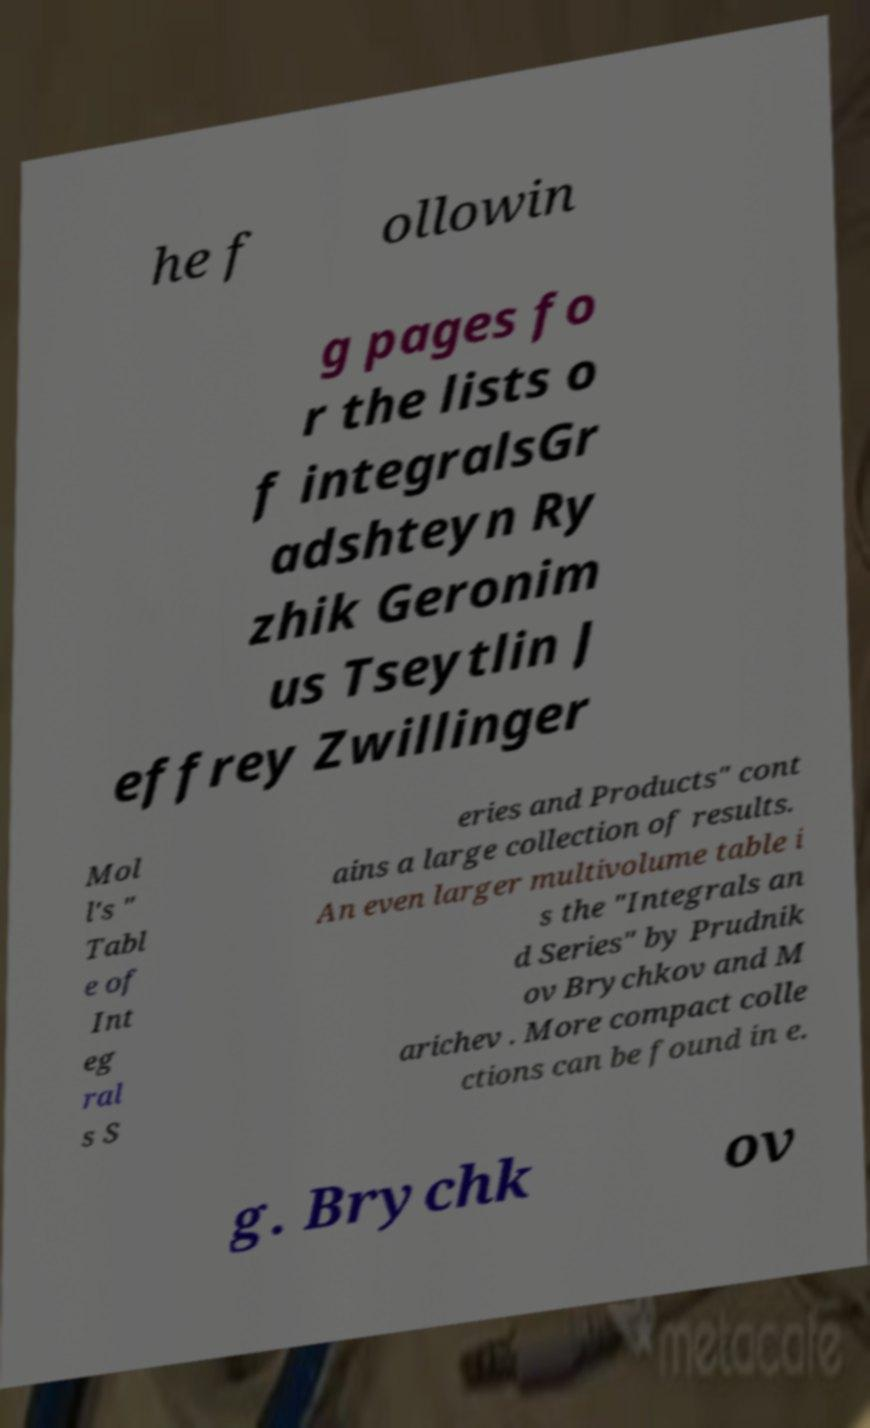Can you accurately transcribe the text from the provided image for me? he f ollowin g pages fo r the lists o f integralsGr adshteyn Ry zhik Geronim us Tseytlin J effrey Zwillinger Mol l's " Tabl e of Int eg ral s S eries and Products" cont ains a large collection of results. An even larger multivolume table i s the "Integrals an d Series" by Prudnik ov Brychkov and M arichev . More compact colle ctions can be found in e. g. Brychk ov 